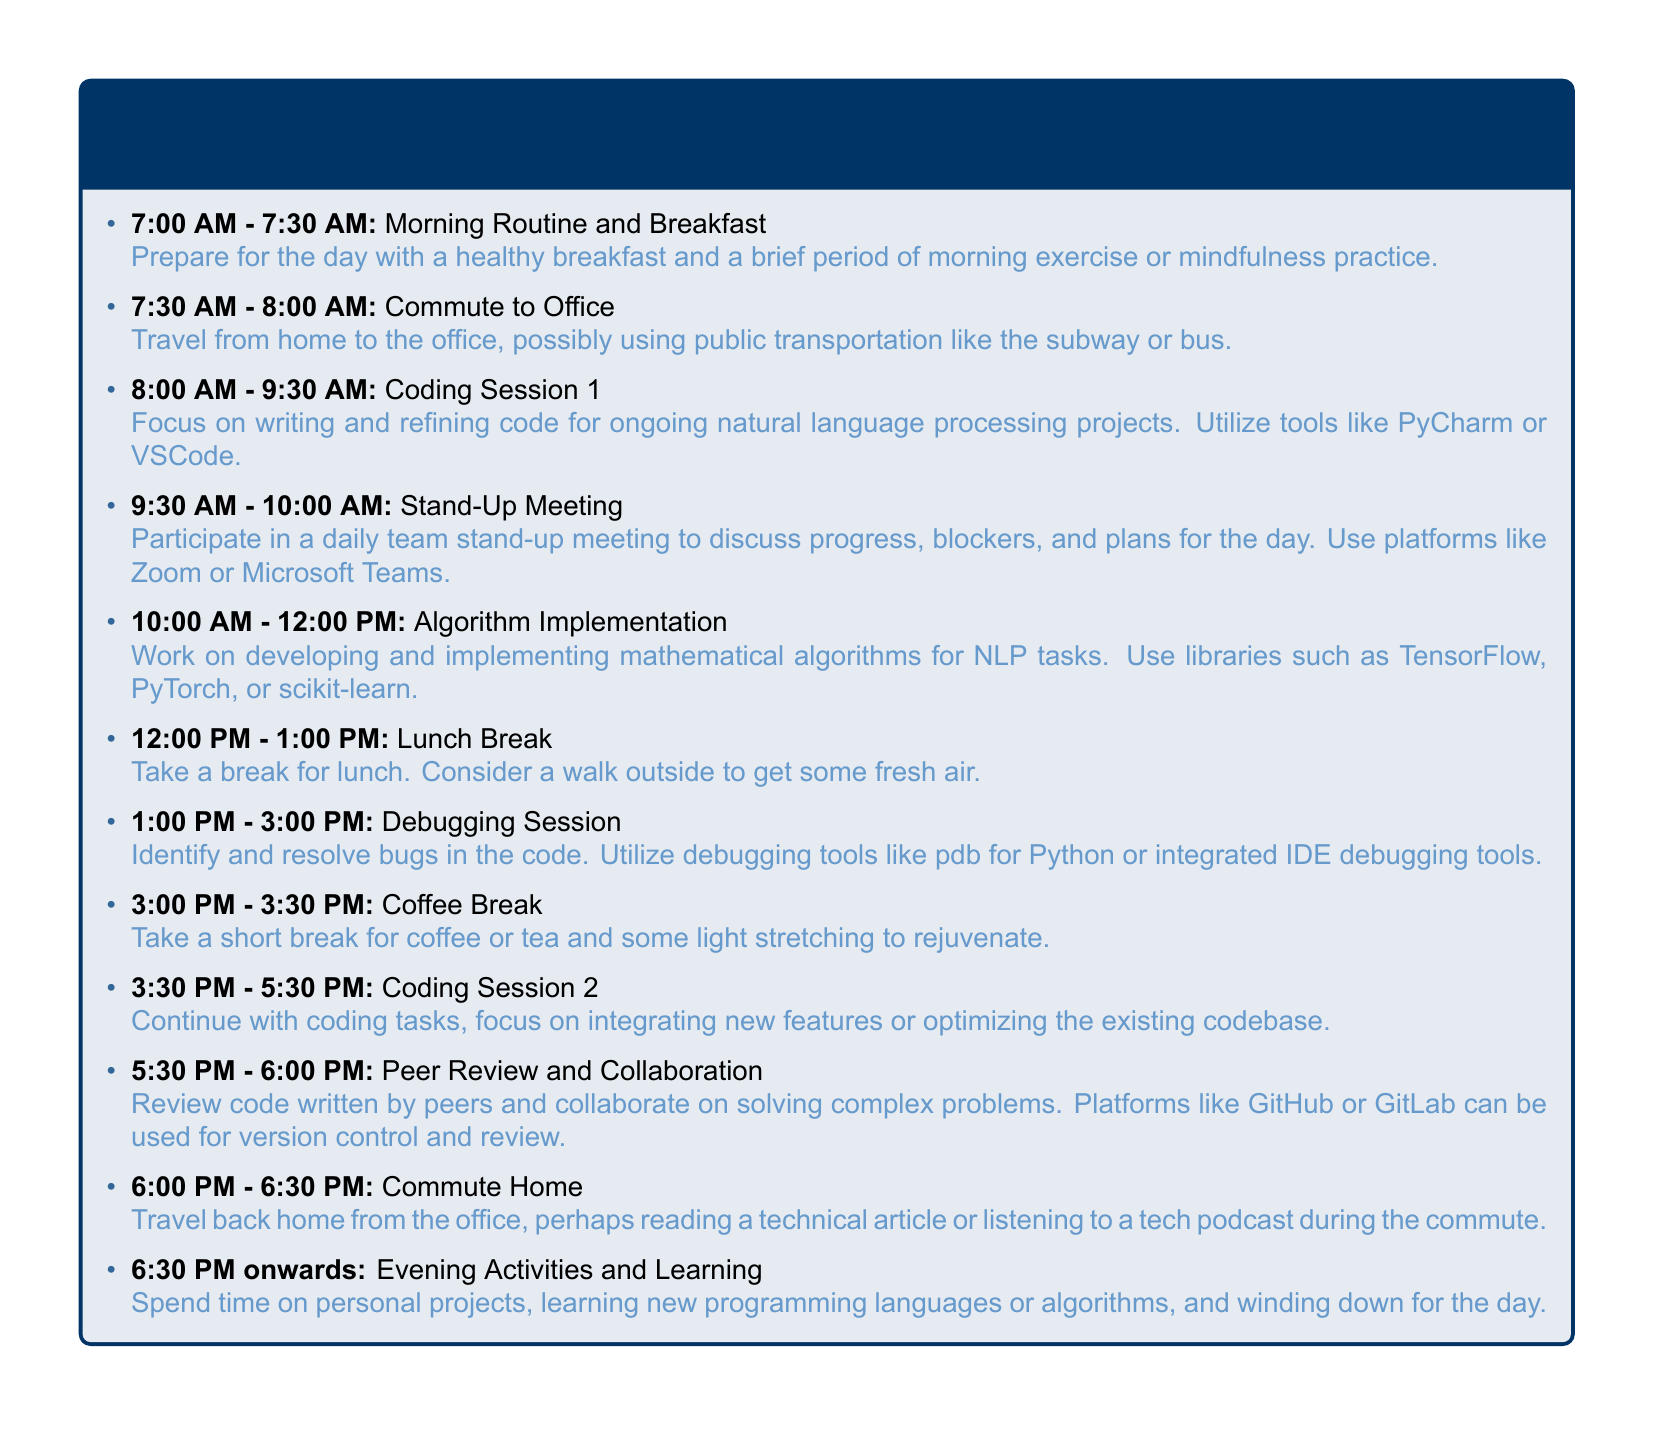what time does morning routine start? The itinerary states that the morning routine begins at 7:00 AM.
Answer: 7:00 AM how long is the lunch break? The document specifies that the lunch break lasts for one hour.
Answer: 1 hour what is the focus during the Algorithm Implementation time slot? The document mentions that this time is for developing and implementing mathematical algorithms for NLP tasks.
Answer: mathematical algorithms for NLP tasks how many coding sessions are there? The itinerary indicates there are two coding sessions throughout the day.
Answer: two what is the duration of the debugging session? It states that the debugging session lasts from 1:00 PM to 3:00 PM, which is two hours in total.
Answer: 2 hours what activity follows the peer review and collaboration? After peer review and collaboration, the itinerary states the time is for commuting home.
Answer: Commute Home what is the purpose of the stand-up meeting? The document notes that the stand-up meeting focuses on discussing progress, blockers, and plans for the day.
Answer: discussing progress, blockers, and plans what is the final activity of the day? The itinerary describes evening activities and learning as the final activity.
Answer: Evening Activities and Learning 